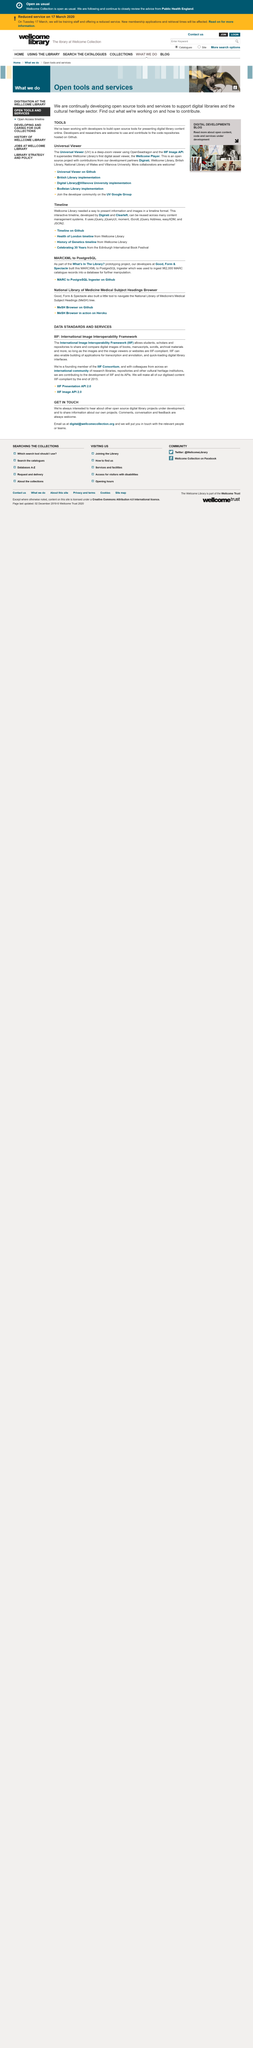Point out several critical features in this image. By the end of 2015, all digitized content will be IIIF-compliant. The acronym IIIF stands for International Image Interoperability Framework. The International Image Interoperability Framework (IIIF) is a system designed to facilitate the sharing and comparison of digital images of various media, including books, manuscripts, scrolls, and archival materials, as long as they are compliant with the IIIF standards. 